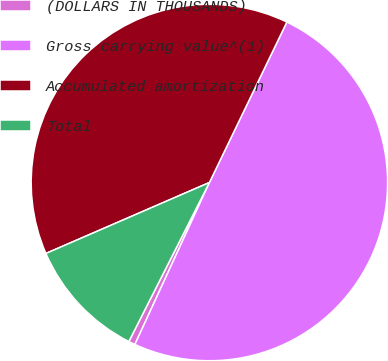<chart> <loc_0><loc_0><loc_500><loc_500><pie_chart><fcel>(DOLLARS IN THOUSANDS)<fcel>Gross carrying value^(1)<fcel>Accumulated amortization<fcel>Total<nl><fcel>0.6%<fcel>49.7%<fcel>38.67%<fcel>11.02%<nl></chart> 